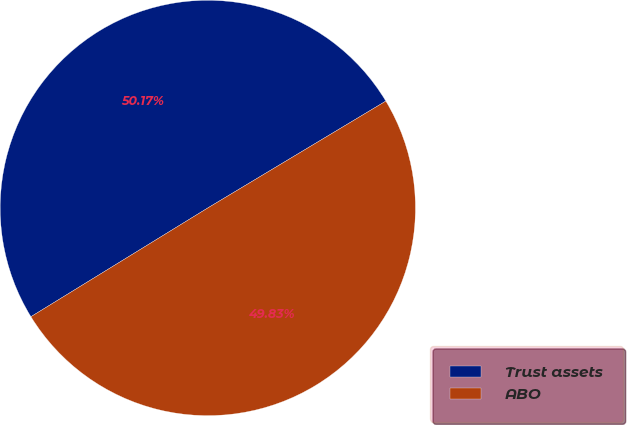Convert chart to OTSL. <chart><loc_0><loc_0><loc_500><loc_500><pie_chart><fcel>Trust assets<fcel>ABO<nl><fcel>50.17%<fcel>49.83%<nl></chart> 